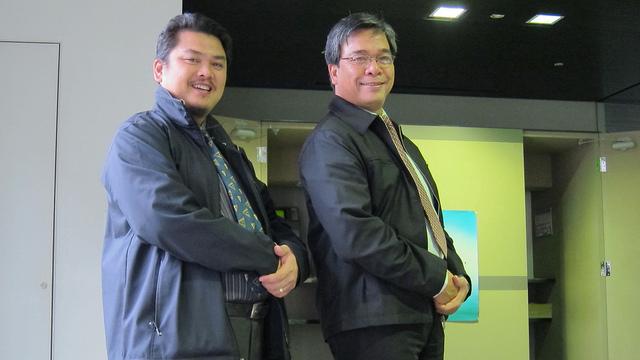What color jacket are the men wearing?
Concise answer only. Black. What is he wearing on his face?
Quick response, please. Glasses. Are they both wearing glasses?
Write a very short answer. No. Who has the better looking tie?
Short answer required. Man on left. How many men are dressed in black?
Answer briefly. 2. 